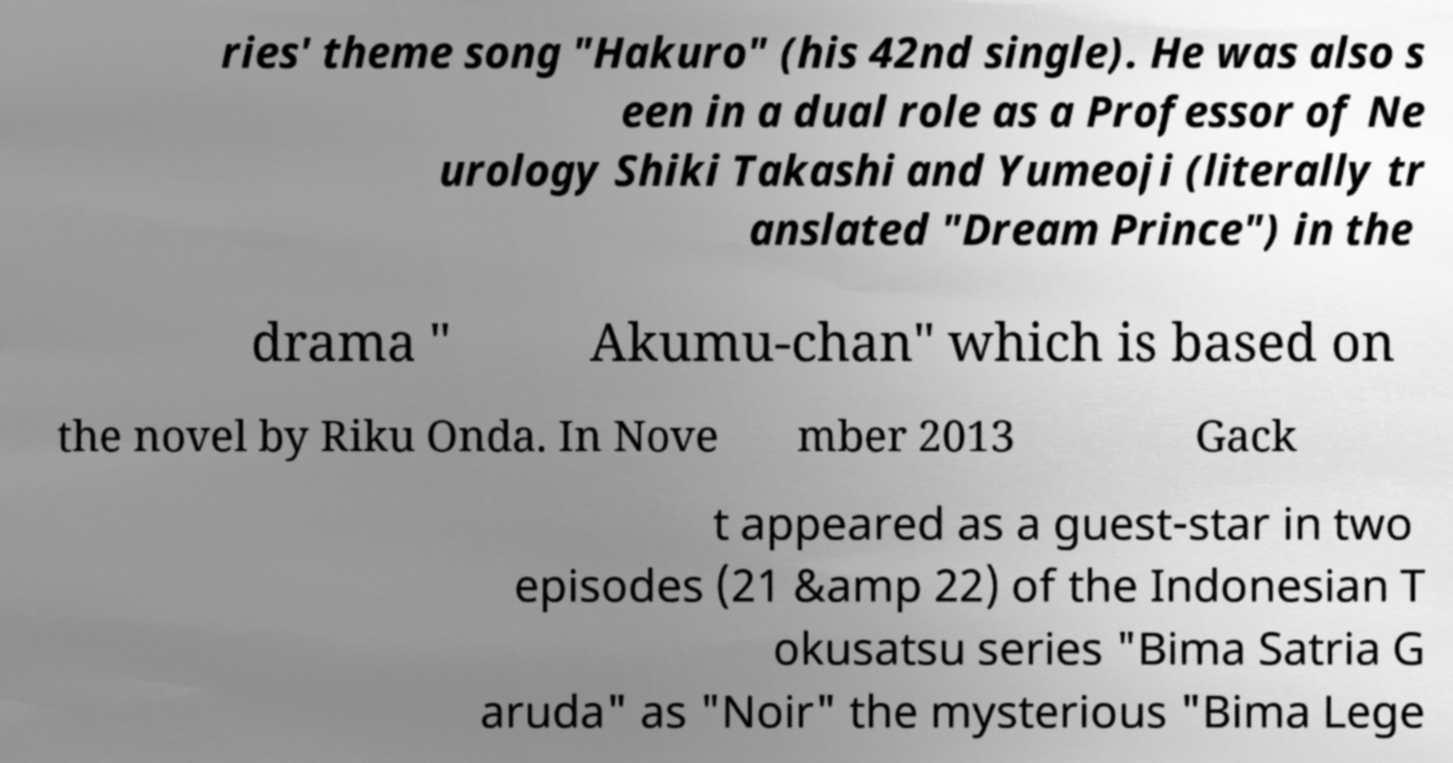Can you accurately transcribe the text from the provided image for me? ries' theme song "Hakuro" (his 42nd single). He was also s een in a dual role as a Professor of Ne urology Shiki Takashi and Yumeoji (literally tr anslated "Dream Prince") in the drama " Akumu-chan" which is based on the novel by Riku Onda. In Nove mber 2013 Gack t appeared as a guest-star in two episodes (21 &amp 22) of the Indonesian T okusatsu series "Bima Satria G aruda" as "Noir" the mysterious "Bima Lege 